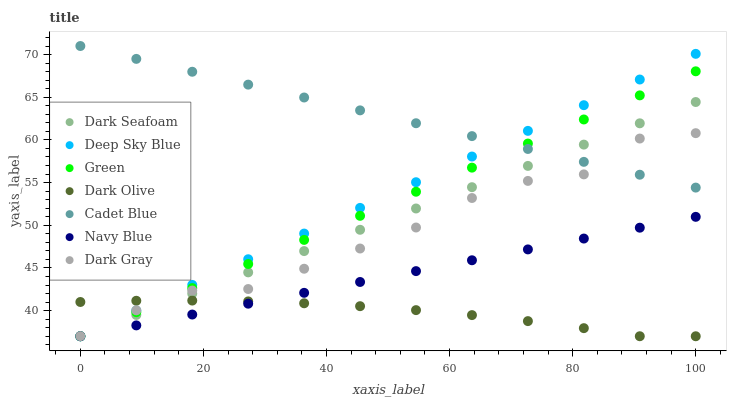Does Dark Olive have the minimum area under the curve?
Answer yes or no. Yes. Does Cadet Blue have the maximum area under the curve?
Answer yes or no. Yes. Does Navy Blue have the minimum area under the curve?
Answer yes or no. No. Does Navy Blue have the maximum area under the curve?
Answer yes or no. No. Is Navy Blue the smoothest?
Answer yes or no. Yes. Is Dark Gray the roughest?
Answer yes or no. Yes. Is Dark Olive the smoothest?
Answer yes or no. No. Is Dark Olive the roughest?
Answer yes or no. No. Does Navy Blue have the lowest value?
Answer yes or no. Yes. Does Dark Gray have the lowest value?
Answer yes or no. No. Does Cadet Blue have the highest value?
Answer yes or no. Yes. Does Navy Blue have the highest value?
Answer yes or no. No. Is Navy Blue less than Dark Gray?
Answer yes or no. Yes. Is Cadet Blue greater than Navy Blue?
Answer yes or no. Yes. Does Dark Seafoam intersect Deep Sky Blue?
Answer yes or no. Yes. Is Dark Seafoam less than Deep Sky Blue?
Answer yes or no. No. Is Dark Seafoam greater than Deep Sky Blue?
Answer yes or no. No. Does Navy Blue intersect Dark Gray?
Answer yes or no. No. 